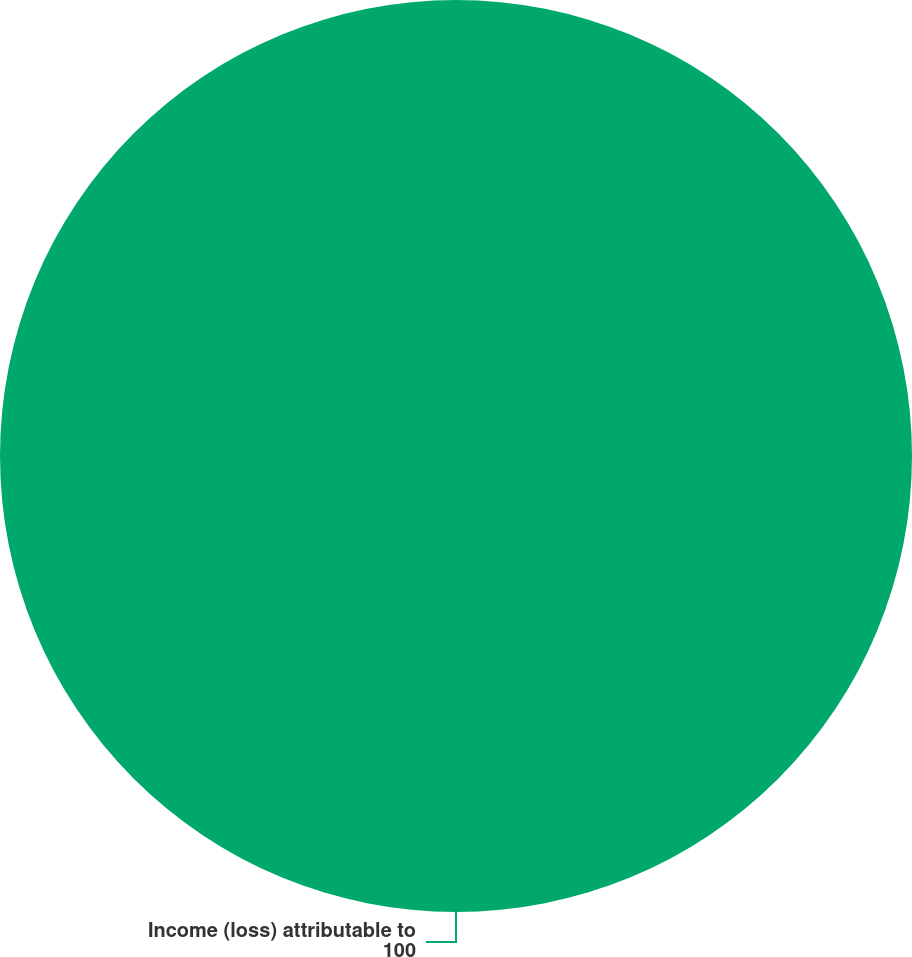Convert chart to OTSL. <chart><loc_0><loc_0><loc_500><loc_500><pie_chart><fcel>Income (loss) attributable to<nl><fcel>100.0%<nl></chart> 